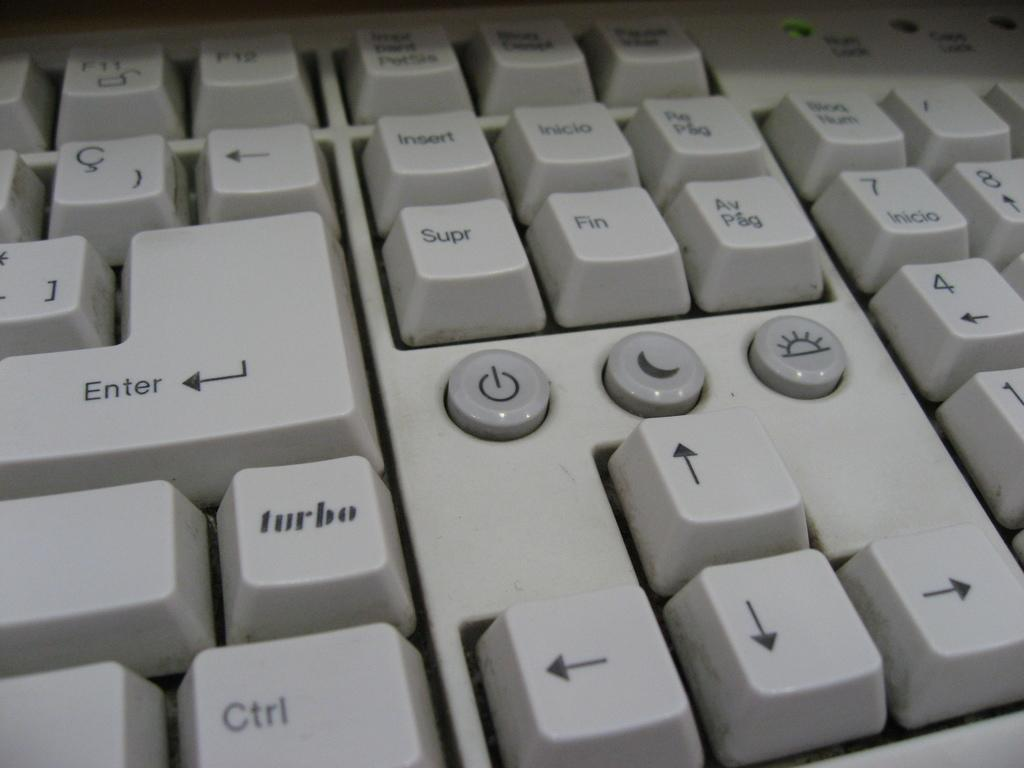<image>
Summarize the visual content of the image. A closeup of a white keyboard with an unusual "turbo" key 